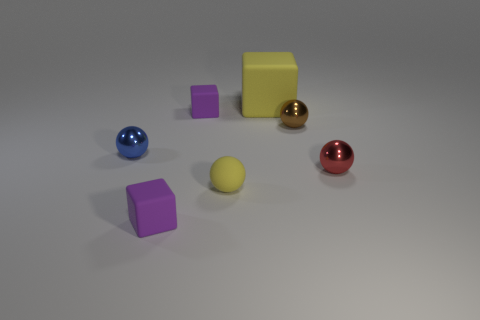What number of other things are there of the same size as the yellow matte block?
Offer a terse response. 0. Is there anything else that has the same material as the tiny red object?
Ensure brevity in your answer.  Yes. Do the small brown thing and the yellow object on the right side of the small yellow matte sphere have the same material?
Your answer should be compact. No. The small metal thing to the left of the yellow thing that is behind the brown thing is what shape?
Provide a short and direct response. Sphere. What number of large things are brown shiny spheres or yellow spheres?
Your answer should be compact. 0. What number of other yellow objects are the same shape as the big yellow rubber thing?
Your response must be concise. 0. There is a tiny brown shiny object; is its shape the same as the small shiny thing on the left side of the brown ball?
Your answer should be compact. Yes. There is a small blue metallic ball; how many rubber objects are in front of it?
Your answer should be very brief. 2. Are there any brown things that have the same size as the yellow rubber sphere?
Offer a very short reply. Yes. Is the shape of the shiny thing to the left of the large yellow object the same as  the brown object?
Offer a terse response. Yes. 